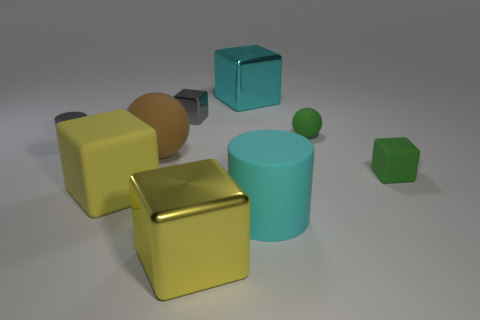Is the small shiny cylinder the same color as the small shiny block?
Your answer should be very brief. Yes. Do the cyan object that is left of the big cyan cylinder and the large shiny object that is in front of the cyan metal thing have the same shape?
Your response must be concise. Yes. What number of other things are the same size as the cyan shiny cube?
Ensure brevity in your answer.  4. The green rubber ball is what size?
Offer a terse response. Small. Does the green thing in front of the green rubber ball have the same material as the large brown ball?
Make the answer very short. Yes. What color is the other small matte object that is the same shape as the brown matte object?
Provide a short and direct response. Green. Is the color of the big metal object in front of the cyan matte cylinder the same as the large matte cube?
Provide a succinct answer. Yes. Are there any large cyan shiny blocks behind the large rubber cylinder?
Offer a very short reply. Yes. There is a tiny object that is in front of the gray block and left of the cyan block; what is its color?
Provide a succinct answer. Gray. What is the shape of the large shiny object that is the same color as the large cylinder?
Keep it short and to the point. Cube. 